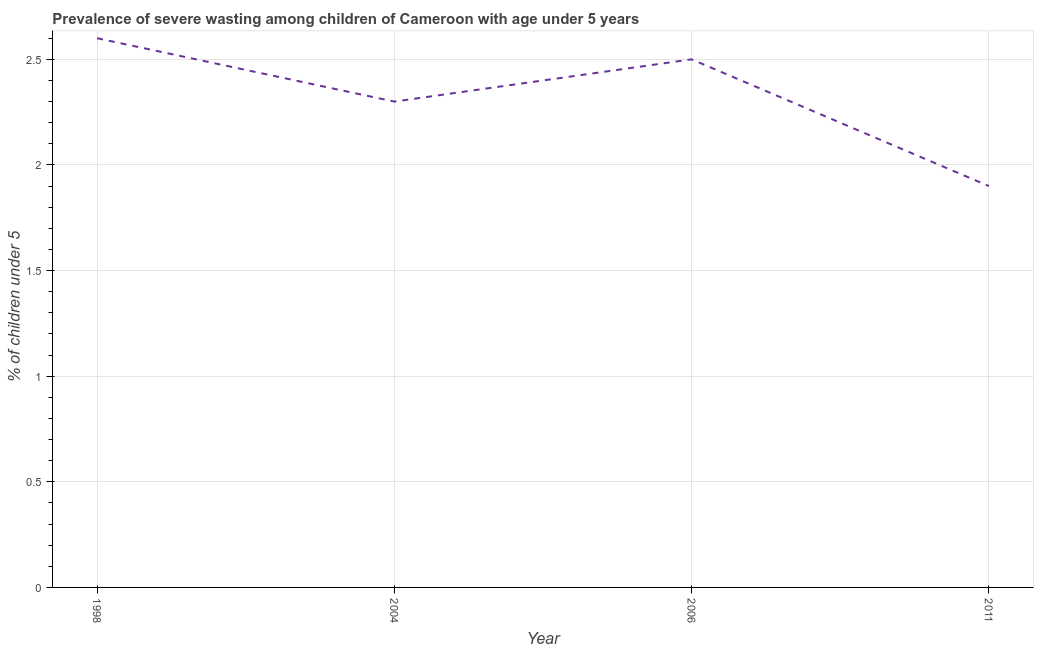Across all years, what is the maximum prevalence of severe wasting?
Provide a short and direct response. 2.6. Across all years, what is the minimum prevalence of severe wasting?
Provide a succinct answer. 1.9. In which year was the prevalence of severe wasting maximum?
Make the answer very short. 1998. What is the sum of the prevalence of severe wasting?
Ensure brevity in your answer.  9.3. What is the difference between the prevalence of severe wasting in 1998 and 2006?
Your answer should be compact. 0.1. What is the average prevalence of severe wasting per year?
Your response must be concise. 2.32. What is the median prevalence of severe wasting?
Your answer should be very brief. 2.4. In how many years, is the prevalence of severe wasting greater than 0.5 %?
Keep it short and to the point. 4. Do a majority of the years between 2006 and 2011 (inclusive) have prevalence of severe wasting greater than 0.7 %?
Offer a very short reply. Yes. What is the ratio of the prevalence of severe wasting in 1998 to that in 2011?
Provide a short and direct response. 1.37. Is the prevalence of severe wasting in 1998 less than that in 2006?
Provide a succinct answer. No. What is the difference between the highest and the second highest prevalence of severe wasting?
Your answer should be very brief. 0.1. Is the sum of the prevalence of severe wasting in 1998 and 2004 greater than the maximum prevalence of severe wasting across all years?
Offer a very short reply. Yes. What is the difference between the highest and the lowest prevalence of severe wasting?
Your answer should be compact. 0.7. In how many years, is the prevalence of severe wasting greater than the average prevalence of severe wasting taken over all years?
Your answer should be very brief. 2. How many lines are there?
Give a very brief answer. 1. How many years are there in the graph?
Give a very brief answer. 4. Are the values on the major ticks of Y-axis written in scientific E-notation?
Your answer should be very brief. No. Does the graph contain any zero values?
Provide a succinct answer. No. What is the title of the graph?
Make the answer very short. Prevalence of severe wasting among children of Cameroon with age under 5 years. What is the label or title of the Y-axis?
Provide a short and direct response.  % of children under 5. What is the  % of children under 5 of 1998?
Ensure brevity in your answer.  2.6. What is the  % of children under 5 of 2004?
Your response must be concise. 2.3. What is the  % of children under 5 of 2006?
Give a very brief answer. 2.5. What is the  % of children under 5 in 2011?
Provide a succinct answer. 1.9. What is the difference between the  % of children under 5 in 1998 and 2006?
Offer a terse response. 0.1. What is the difference between the  % of children under 5 in 1998 and 2011?
Your answer should be compact. 0.7. What is the difference between the  % of children under 5 in 2004 and 2011?
Offer a very short reply. 0.4. What is the difference between the  % of children under 5 in 2006 and 2011?
Make the answer very short. 0.6. What is the ratio of the  % of children under 5 in 1998 to that in 2004?
Make the answer very short. 1.13. What is the ratio of the  % of children under 5 in 1998 to that in 2011?
Ensure brevity in your answer.  1.37. What is the ratio of the  % of children under 5 in 2004 to that in 2011?
Give a very brief answer. 1.21. What is the ratio of the  % of children under 5 in 2006 to that in 2011?
Offer a very short reply. 1.32. 